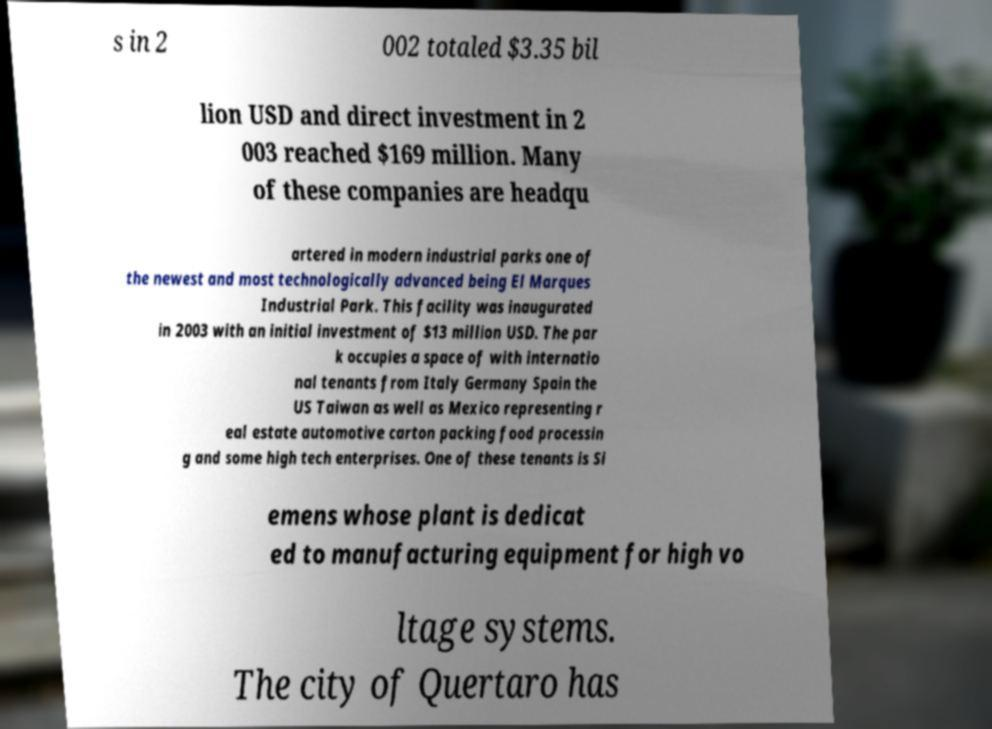For documentation purposes, I need the text within this image transcribed. Could you provide that? s in 2 002 totaled $3.35 bil lion USD and direct investment in 2 003 reached $169 million. Many of these companies are headqu artered in modern industrial parks one of the newest and most technologically advanced being El Marques Industrial Park. This facility was inaugurated in 2003 with an initial investment of $13 million USD. The par k occupies a space of with internatio nal tenants from Italy Germany Spain the US Taiwan as well as Mexico representing r eal estate automotive carton packing food processin g and some high tech enterprises. One of these tenants is Si emens whose plant is dedicat ed to manufacturing equipment for high vo ltage systems. The city of Quertaro has 